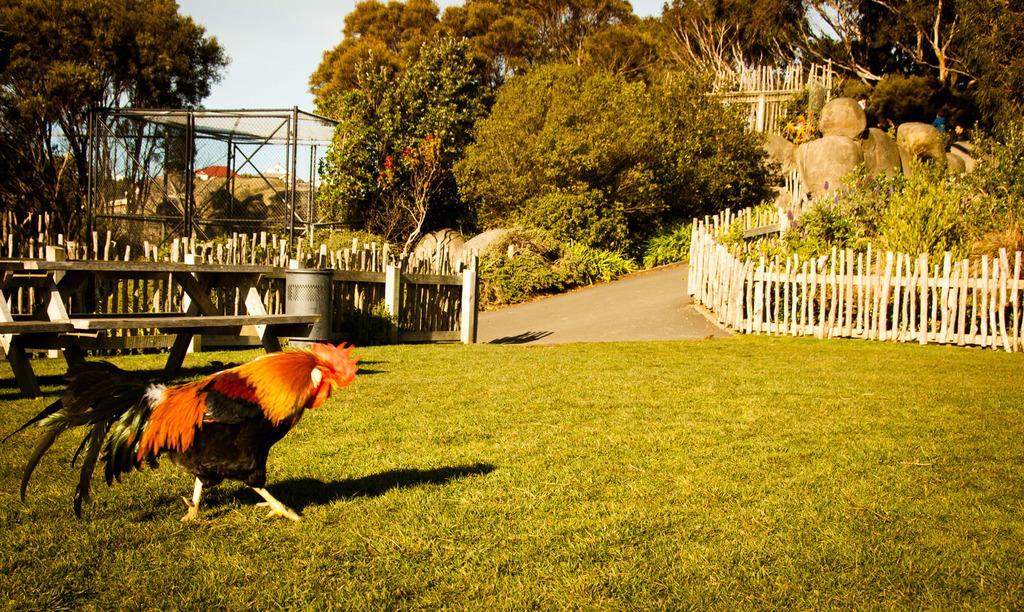Could you give a brief overview of what you see in this image? In this image I can see a red jungle fowl on the grass. In the background I can see a fence, tent, plants, trees and rocks. On the top left I can see the sky. This image is taken during a sunny day may be in the park. 